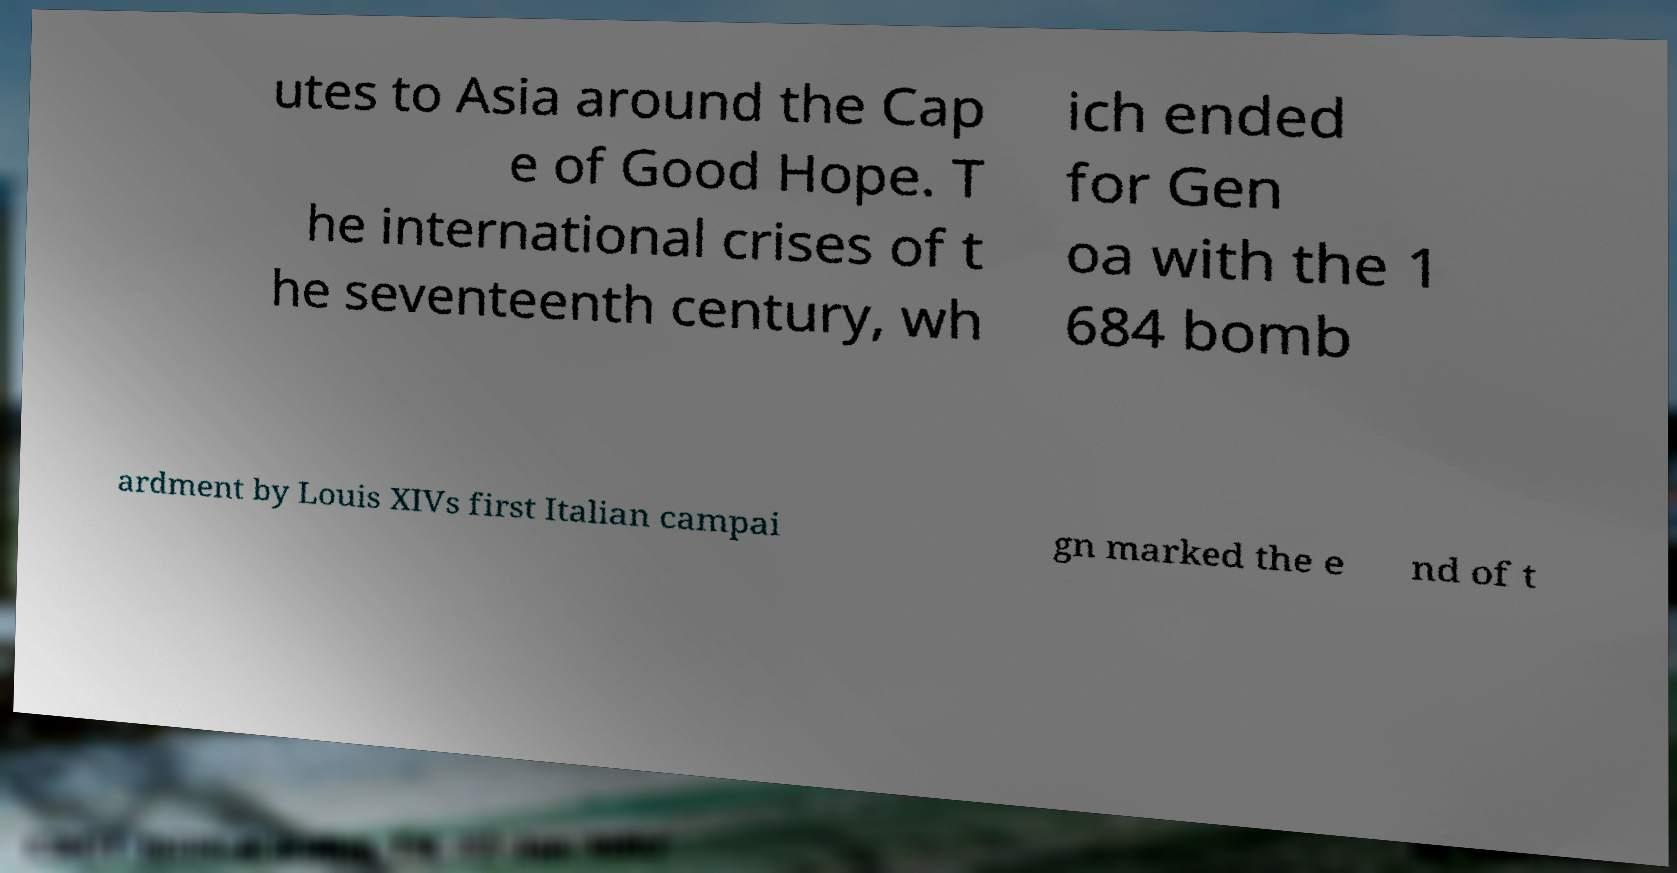Can you accurately transcribe the text from the provided image for me? utes to Asia around the Cap e of Good Hope. T he international crises of t he seventeenth century, wh ich ended for Gen oa with the 1 684 bomb ardment by Louis XIVs first Italian campai gn marked the e nd of t 